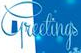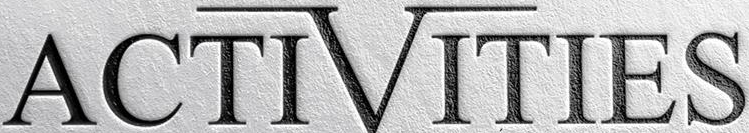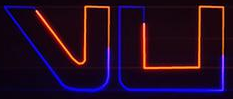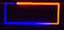Transcribe the words shown in these images in order, separated by a semicolon. Greetings; ACTIVITIES; vu; - 